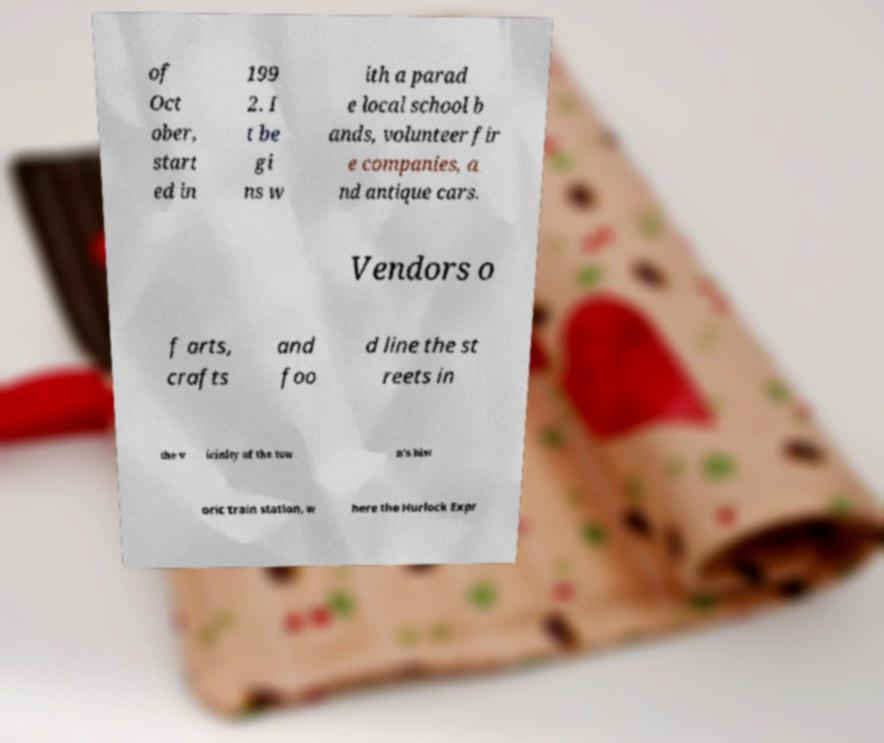Please read and relay the text visible in this image. What does it say? of Oct ober, start ed in 199 2. I t be gi ns w ith a parad e local school b ands, volunteer fir e companies, a nd antique cars. Vendors o f arts, crafts and foo d line the st reets in the v icinity of the tow n's hist oric train station, w here the Hurlock Expr 